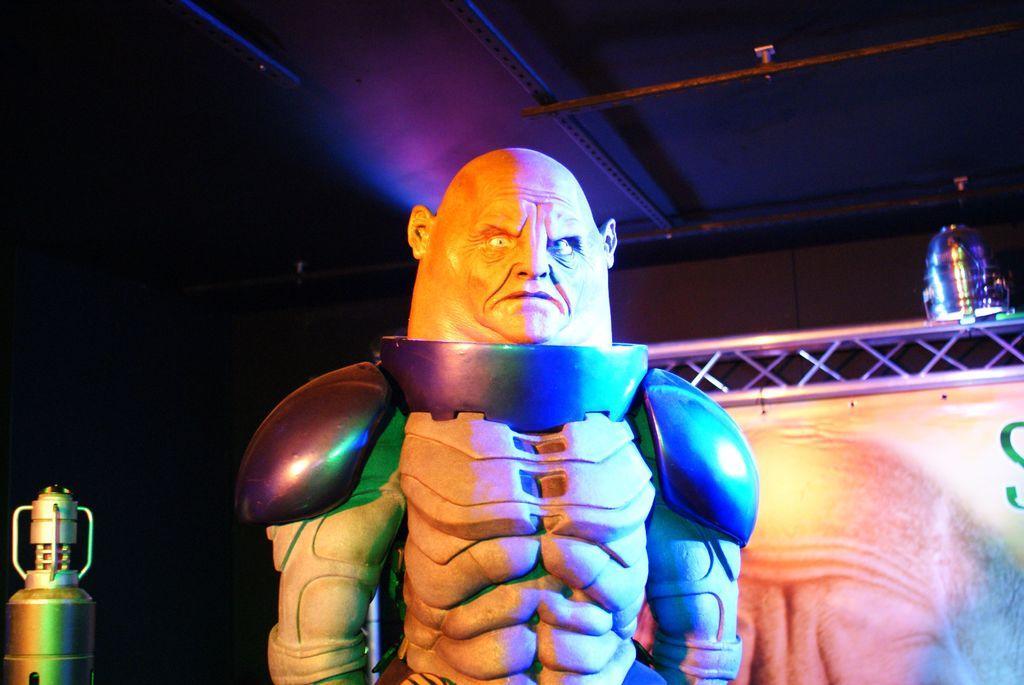Please provide a concise description of this image. In the foreground of this image, there is a statue like structure and in the background, there is a banner, light and there is an object on the left side. 